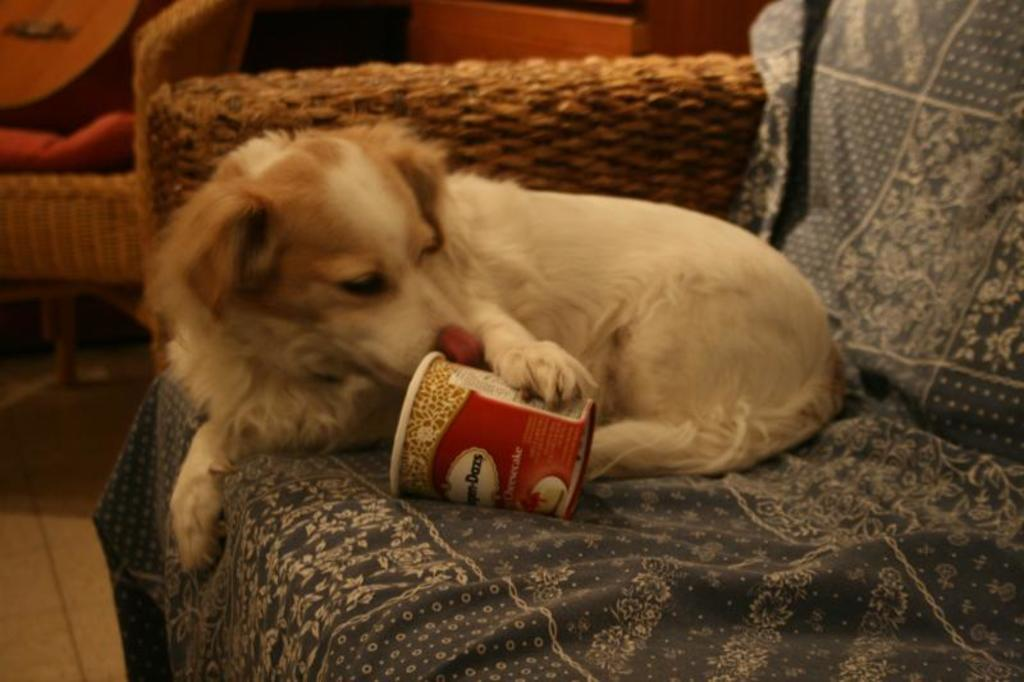What animal can be seen in the image? There is a dog in the image. Where is the dog located? The dog is seated on the sofa. What is covering part of the sofa? There is a cloth on the sofa. What type of container is visible in the image? There is a cup in the image. What colors can be seen on the dog? The dog is white and brown in color. What type of furniture is present in the image besides the sofa? There is a chair with a cushion in the image. How many children are running around the dog in the image? There are no children present in the image, and the dog is seated, so it cannot be running. 